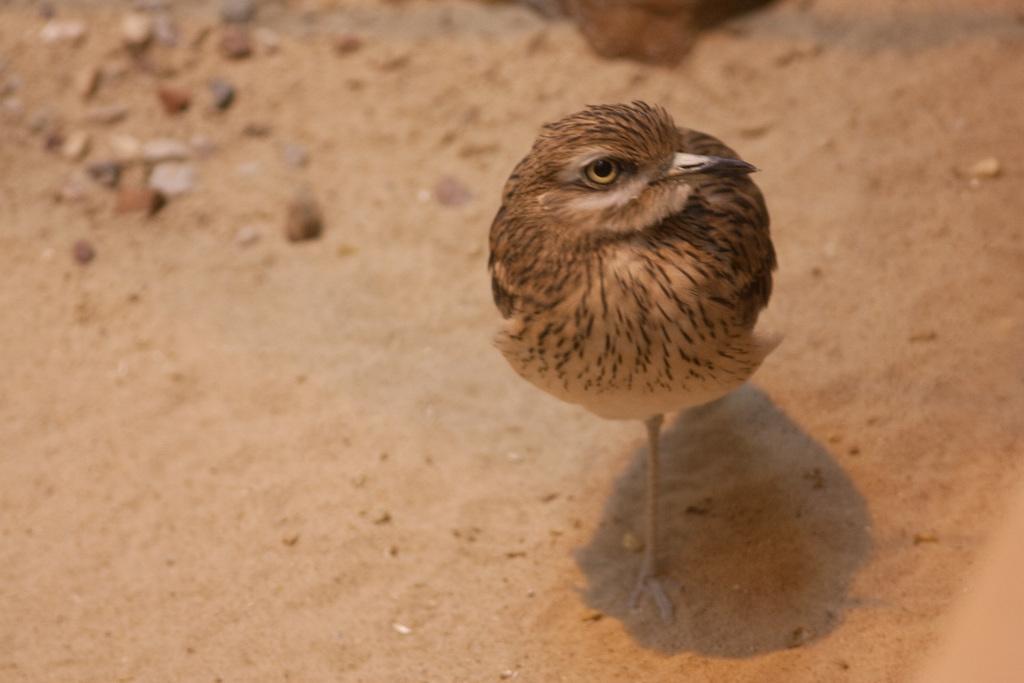Please provide a concise description of this image. In the center of the image, we can see a chick on the ground. 